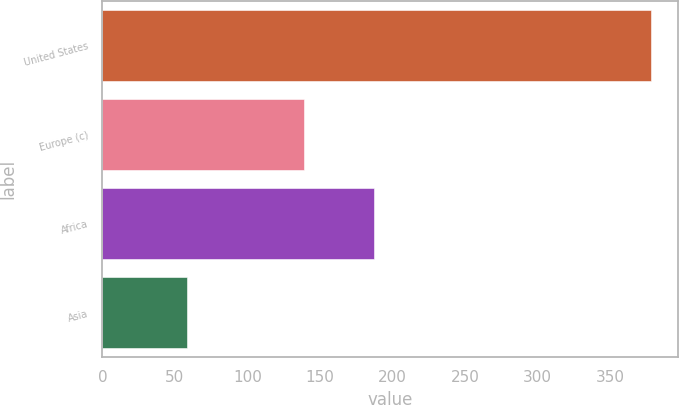<chart> <loc_0><loc_0><loc_500><loc_500><bar_chart><fcel>United States<fcel>Europe (c)<fcel>Africa<fcel>Asia<nl><fcel>378<fcel>139<fcel>187<fcel>58<nl></chart> 